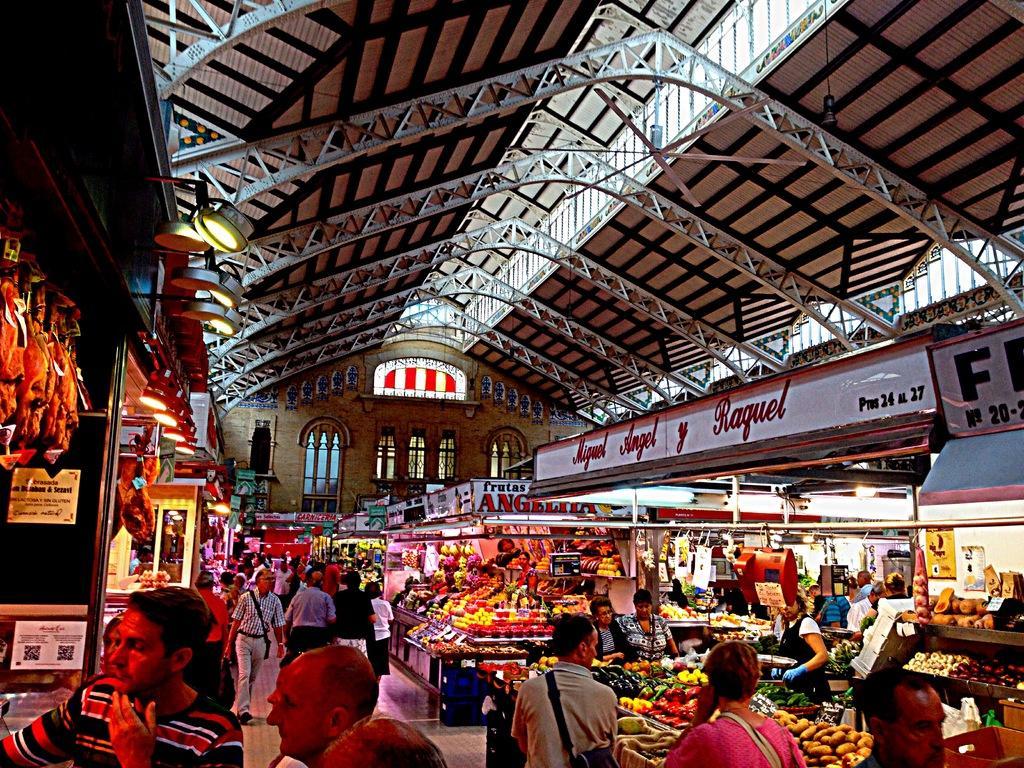Could you give a brief overview of what you see in this image? In this image, we can see few stalls, some objects, stickers, hoardings, lights, wall, glass windows. At the bottom of the image, we can see a group of people. Top of the image, there is a roof with rods. 